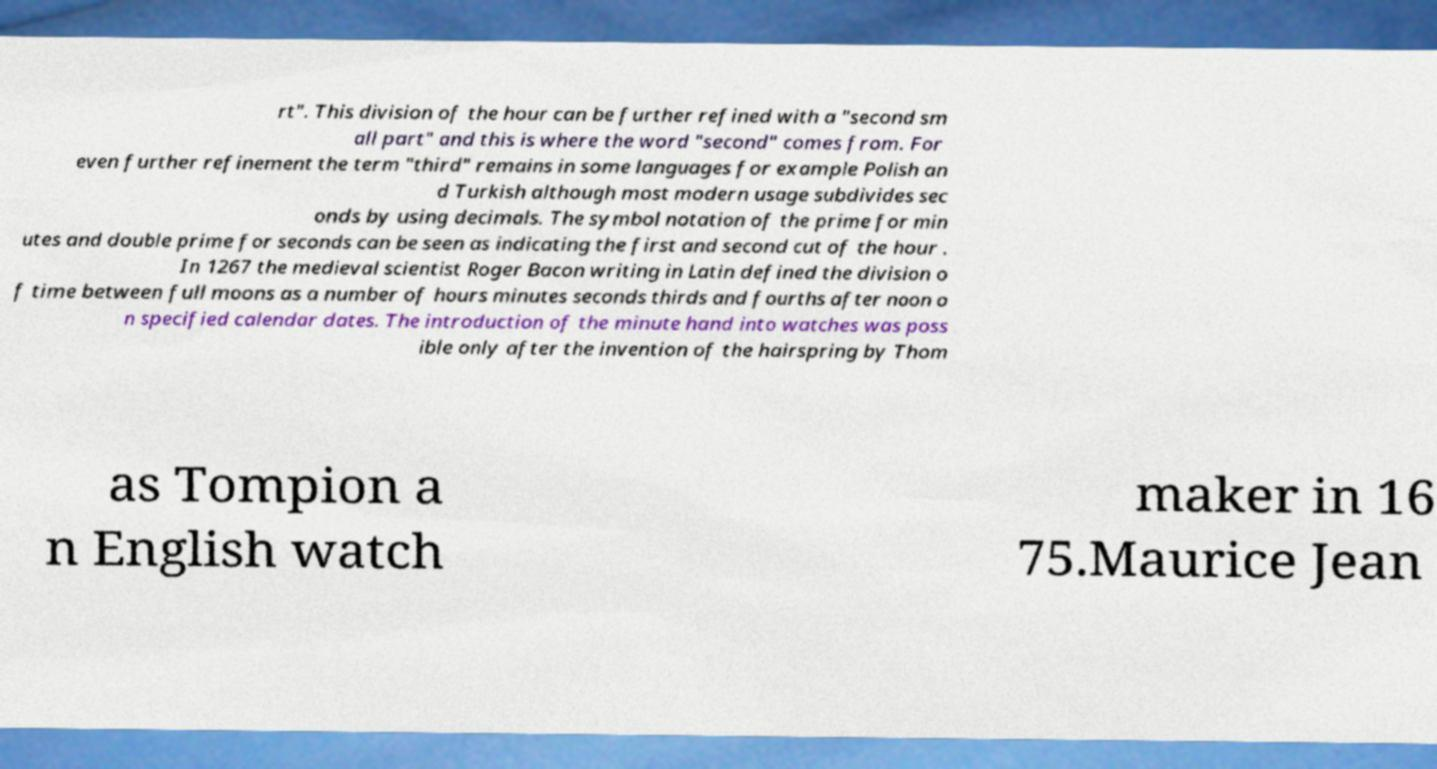What messages or text are displayed in this image? I need them in a readable, typed format. rt". This division of the hour can be further refined with a "second sm all part" and this is where the word "second" comes from. For even further refinement the term "third" remains in some languages for example Polish an d Turkish although most modern usage subdivides sec onds by using decimals. The symbol notation of the prime for min utes and double prime for seconds can be seen as indicating the first and second cut of the hour . In 1267 the medieval scientist Roger Bacon writing in Latin defined the division o f time between full moons as a number of hours minutes seconds thirds and fourths after noon o n specified calendar dates. The introduction of the minute hand into watches was poss ible only after the invention of the hairspring by Thom as Tompion a n English watch maker in 16 75.Maurice Jean 